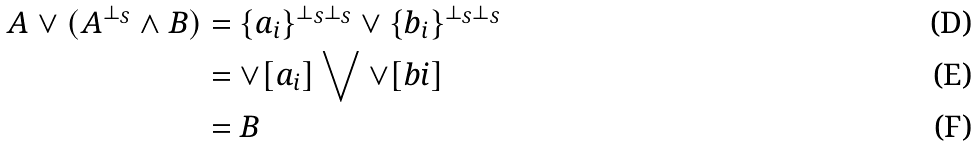<formula> <loc_0><loc_0><loc_500><loc_500>A \vee ( A ^ { \bot _ { S } } \wedge B ) & = \{ a _ { i } \} ^ { \bot _ { S } \bot _ { S } } \vee \{ b _ { i } \} ^ { \bot _ { S } \bot _ { S } } \\ & = \vee [ a _ { i } ] \bigvee \vee [ b i ] \\ & = B</formula> 